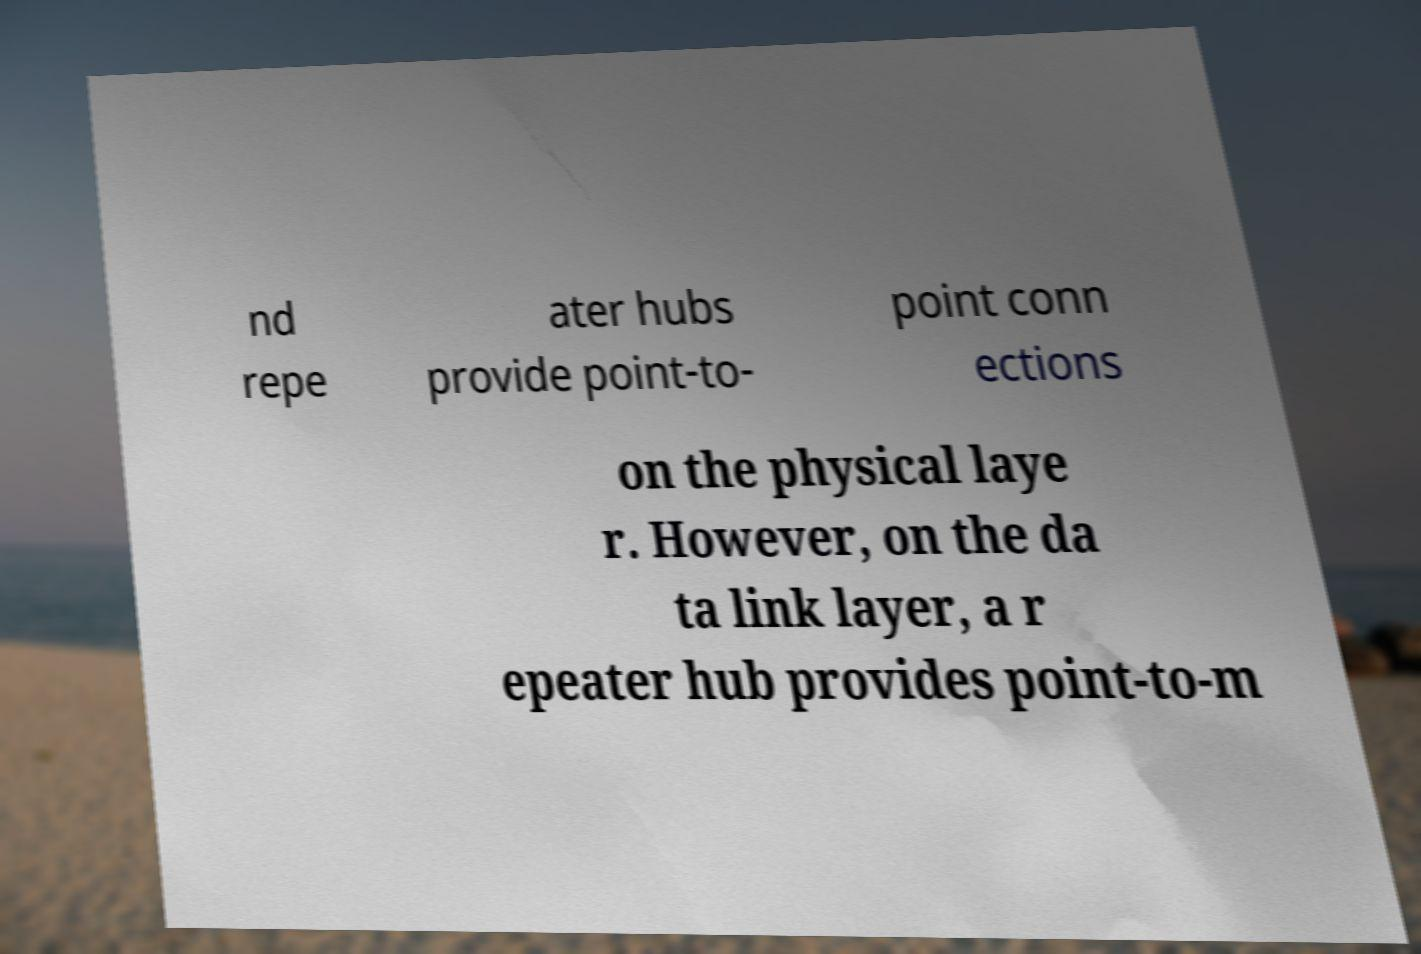Can you accurately transcribe the text from the provided image for me? nd repe ater hubs provide point-to- point conn ections on the physical laye r. However, on the da ta link layer, a r epeater hub provides point-to-m 